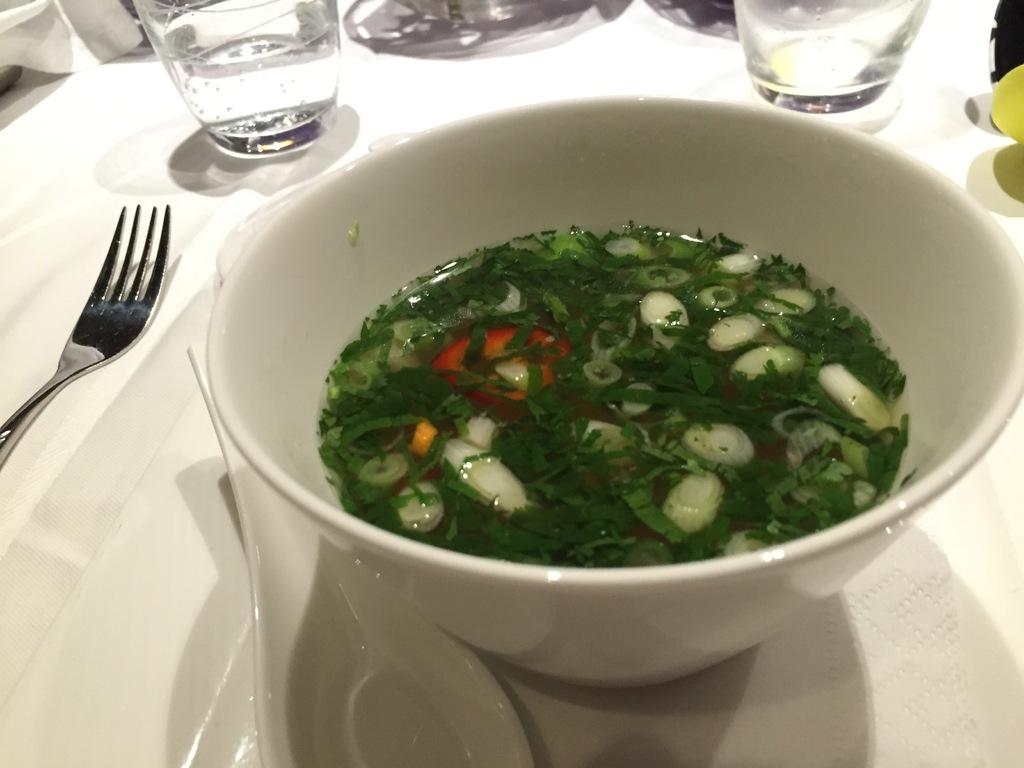What is in the bowl that is visible in the image? There is a bowl with soup in the image. What utensil is visible in the image? A spoon is visible in the image. What other utensil is present in the image? A fork is present in the image. What objects are on the table in the image? There are glasses on the table in the image. How many geese are flying over the table in the image? There are no geese present in the image; it only features a bowl of soup, a spoon, a fork, and glasses on the table. 